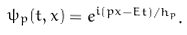Convert formula to latex. <formula><loc_0><loc_0><loc_500><loc_500>\psi _ { p } ( t , x ) = e ^ { i ( { p } x - E t ) / h _ { p } } .</formula> 